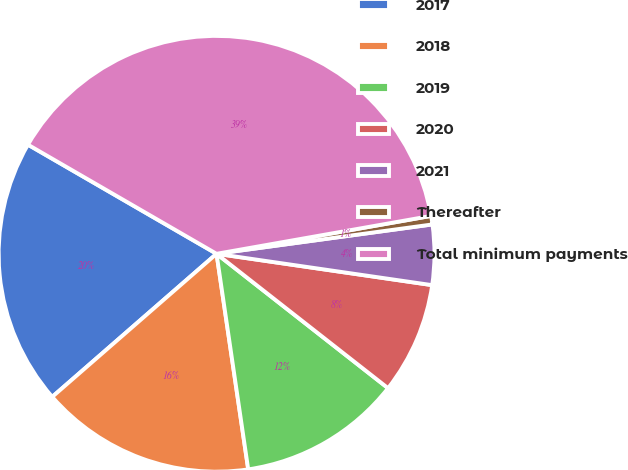Convert chart to OTSL. <chart><loc_0><loc_0><loc_500><loc_500><pie_chart><fcel>2017<fcel>2018<fcel>2019<fcel>2020<fcel>2021<fcel>Thereafter<fcel>Total minimum payments<nl><fcel>19.75%<fcel>15.92%<fcel>12.1%<fcel>8.28%<fcel>4.45%<fcel>0.63%<fcel>38.87%<nl></chart> 